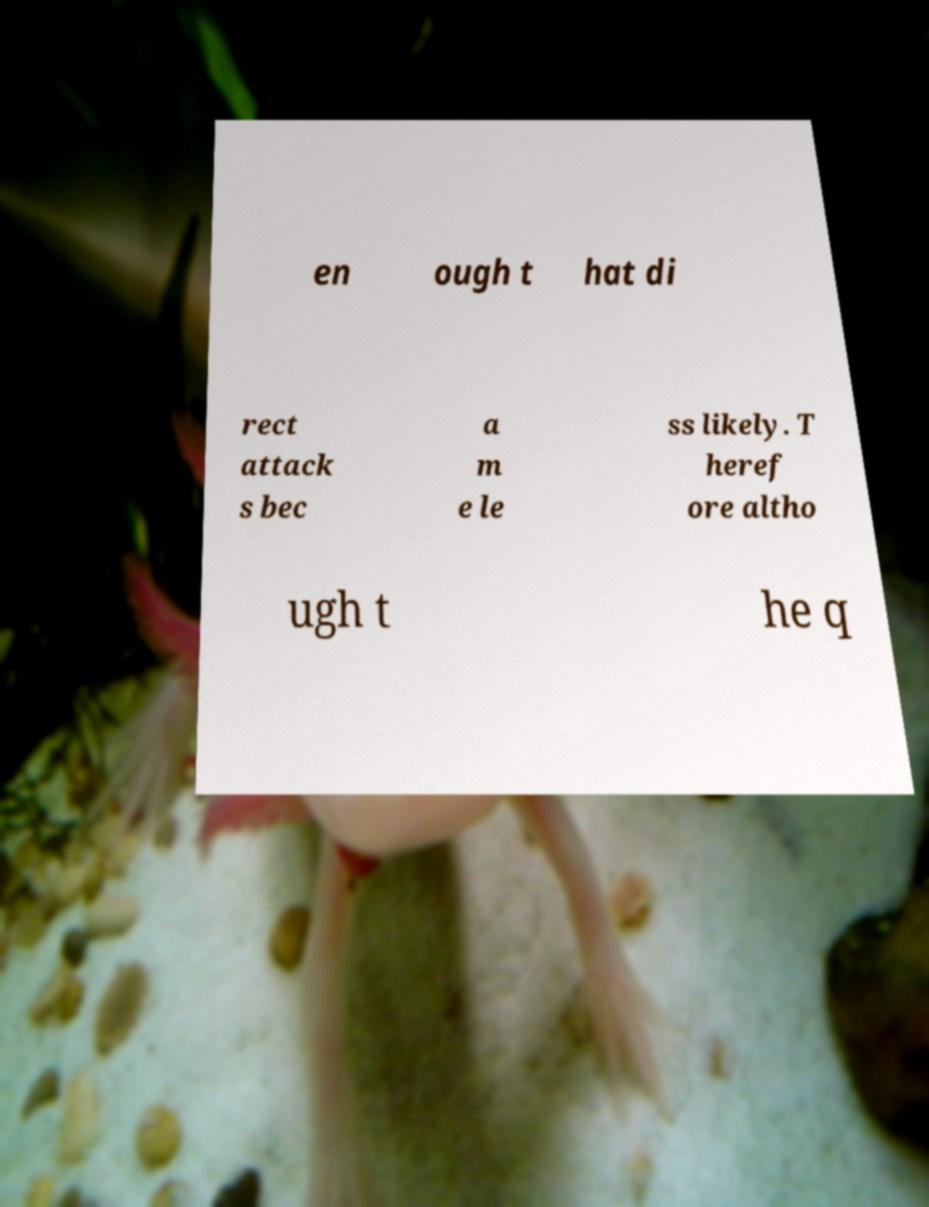Please read and relay the text visible in this image. What does it say? en ough t hat di rect attack s bec a m e le ss likely. T heref ore altho ugh t he q 